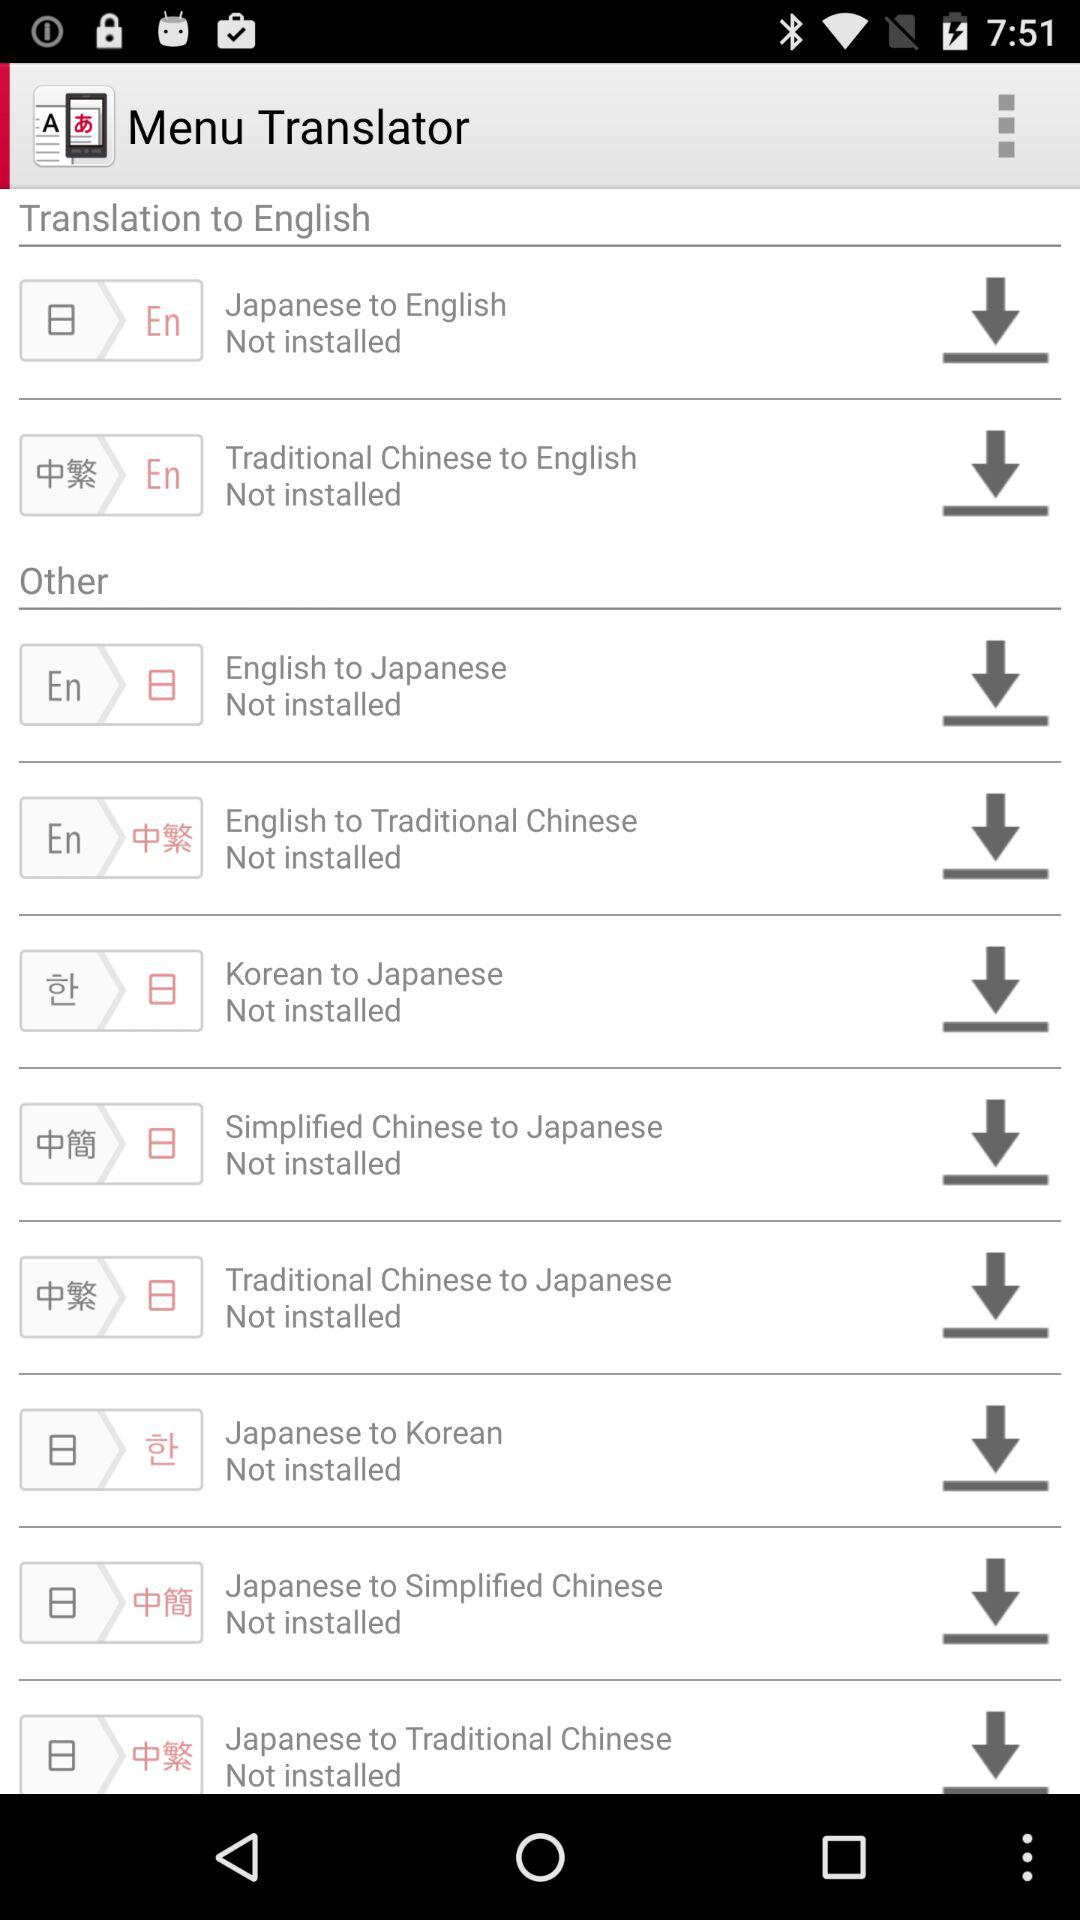Which translator can be used to translate to English? The translators that can be used are "Japanese to English" and "Traditional Chinese to English". 